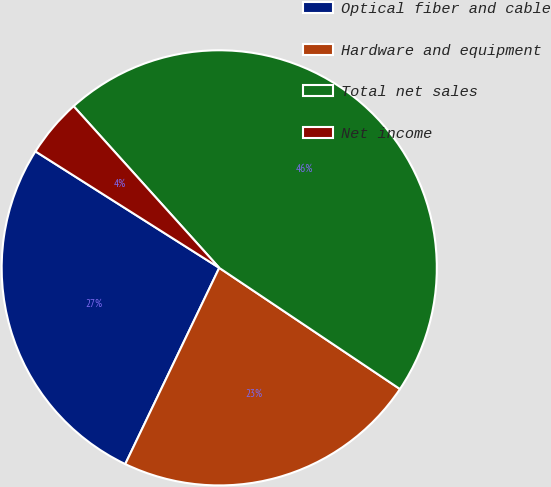Convert chart. <chart><loc_0><loc_0><loc_500><loc_500><pie_chart><fcel>Optical fiber and cable<fcel>Hardware and equipment<fcel>Total net sales<fcel>Net income<nl><fcel>26.88%<fcel>22.71%<fcel>46.08%<fcel>4.34%<nl></chart> 